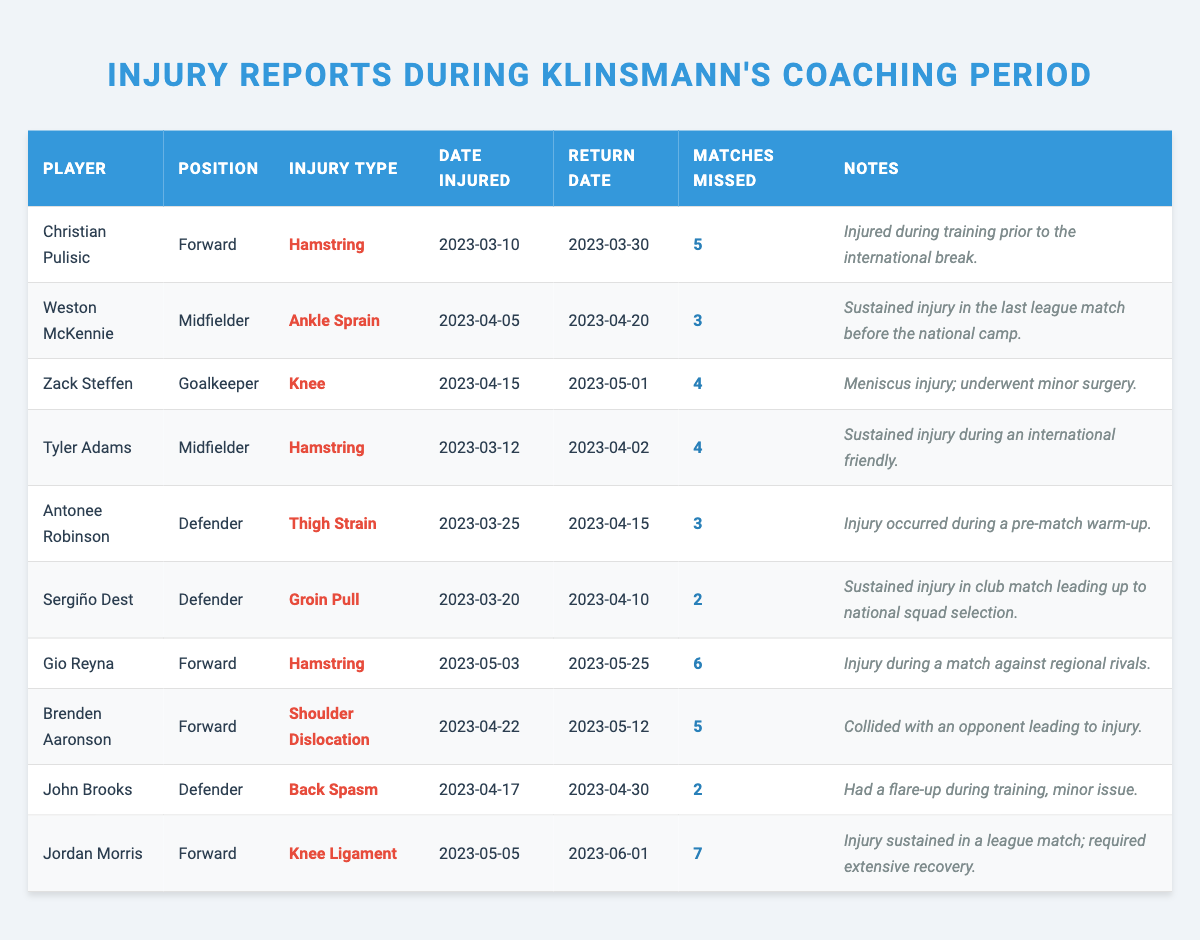What is the injury type for Christian Pulisic? According to the table, Christian Pulisic's injury type is listed as "Hamstring."
Answer: Hamstring How many matches did Weston McKennie miss? The table shows that Weston McKennie missed 3 matches due to his ankle sprain injury.
Answer: 3 Which player suffered a knee ligament injury? The table indicates that Jordan Morris sustained a knee ligament injury.
Answer: Jordan Morris What is the return date for Zach Steffen? According to the table, Zack Steffen's return date is noted as May 1, 2023.
Answer: May 1, 2023 How many players missed more than 5 matches? From the table data, only Gio Reyna and Jordan Morris missed more than 5 matches. Thus, there are 2 players who fit this criterion.
Answer: 2 What is the total number of matches missed by all players listed? Summing the matches missed from the table: 5 (Pulisic) + 3 (McKennie) + 4 (Steffen) + 4 (Adams) + 3 (Robinson) + 2 (Dest) + 6 (Reyna) + 5 (Aaronson) + 2 (Brooks) + 7 (Morris) = 42 matches missed collectively by these players.
Answer: 42 Did any player miss matches due to a shoulder dislocation? Yes, the table shows that Brenden Aaronson missed matches due to a shoulder dislocation.
Answer: Yes What is the average number of matches missed by the players? Calculating the average: There are 10 players, and the total matches missed is 42. Therefore, the average is 42 / 10 = 4.2 matches missed per player.
Answer: 4.2 Which player sustained an injury during training before the international break? The table specifies that Christian Pulisic was injured during training prior to the international break.
Answer: Christian Pulisic If Tyler Adams and Antonee Robinson were both injured for a total of 7 matches, how many matches did each player miss individually? Referring to the table, Tyler Adams missed 4 matches and Antonee Robinson missed 3 matches, which, when added, totals 7 matches.
Answer: 4 for Adams and 3 for Robinson 